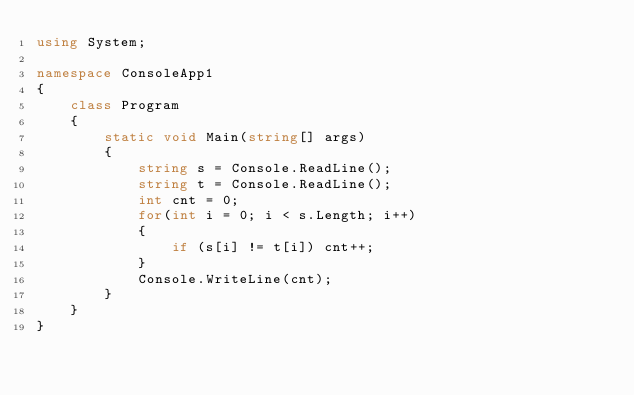Convert code to text. <code><loc_0><loc_0><loc_500><loc_500><_C#_>using System;

namespace ConsoleApp1
{
    class Program
    {
        static void Main(string[] args)
        {
            string s = Console.ReadLine();
            string t = Console.ReadLine();
            int cnt = 0;
            for(int i = 0; i < s.Length; i++)
            {
                if (s[i] != t[i]) cnt++;
            }
            Console.WriteLine(cnt);
        }
    }
}
</code> 